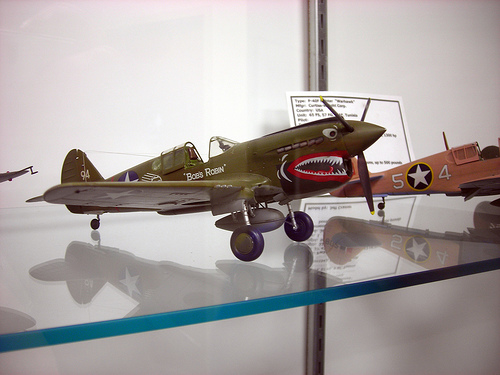<image>
Is the plane on the glass? Yes. Looking at the image, I can see the plane is positioned on top of the glass, with the glass providing support. 